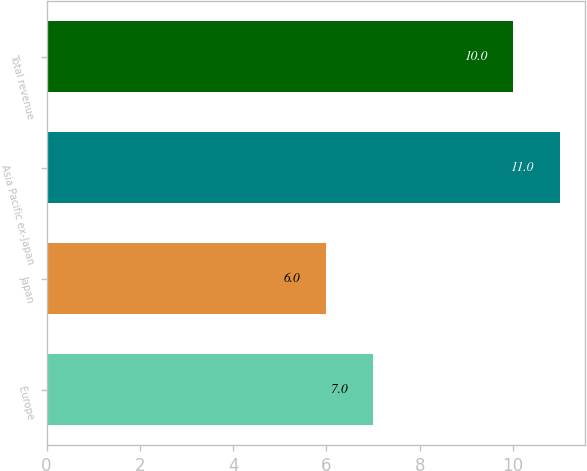Convert chart to OTSL. <chart><loc_0><loc_0><loc_500><loc_500><bar_chart><fcel>Europe<fcel>Japan<fcel>Asia Pacific ex-Japan<fcel>Total revenue<nl><fcel>7<fcel>6<fcel>11<fcel>10<nl></chart> 